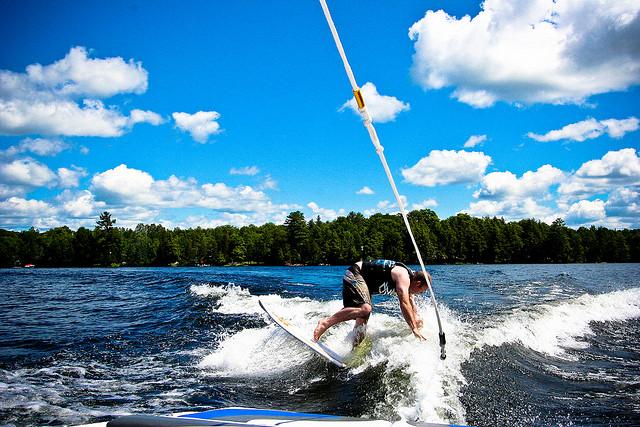What is the cord for?
Keep it brief. Pulling. Is this nice weather?
Keep it brief. Yes. How many people are in  the  water?
Keep it brief. 1. 